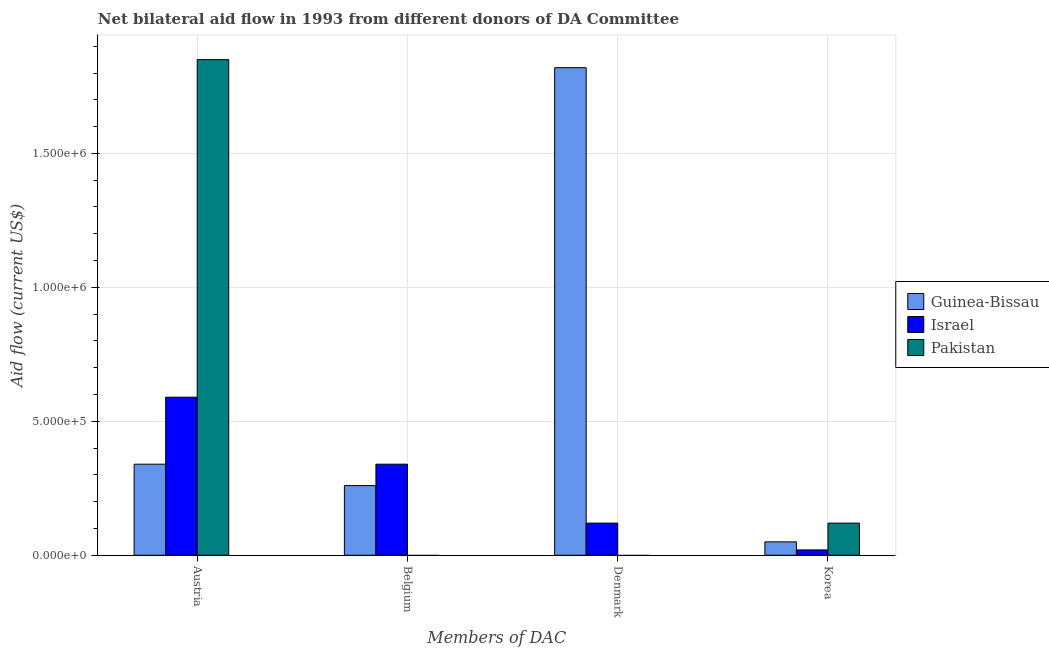How many different coloured bars are there?
Give a very brief answer. 3. How many groups of bars are there?
Your answer should be compact. 4. Are the number of bars on each tick of the X-axis equal?
Offer a terse response. No. How many bars are there on the 2nd tick from the right?
Provide a succinct answer. 2. What is the label of the 3rd group of bars from the left?
Your answer should be compact. Denmark. What is the amount of aid given by austria in Israel?
Provide a short and direct response. 5.90e+05. Across all countries, what is the maximum amount of aid given by korea?
Your response must be concise. 1.20e+05. Across all countries, what is the minimum amount of aid given by denmark?
Your answer should be compact. 0. What is the total amount of aid given by austria in the graph?
Offer a very short reply. 2.78e+06. What is the difference between the amount of aid given by korea in Pakistan and that in Israel?
Provide a short and direct response. 1.00e+05. What is the difference between the amount of aid given by korea in Guinea-Bissau and the amount of aid given by austria in Israel?
Offer a terse response. -5.40e+05. What is the difference between the amount of aid given by korea and amount of aid given by austria in Guinea-Bissau?
Provide a short and direct response. -2.90e+05. In how many countries, is the amount of aid given by korea greater than 700000 US$?
Provide a short and direct response. 0. What is the ratio of the amount of aid given by austria in Guinea-Bissau to that in Israel?
Provide a short and direct response. 0.58. Is the difference between the amount of aid given by denmark in Israel and Guinea-Bissau greater than the difference between the amount of aid given by korea in Israel and Guinea-Bissau?
Give a very brief answer. No. What is the difference between the highest and the lowest amount of aid given by denmark?
Give a very brief answer. 1.82e+06. In how many countries, is the amount of aid given by belgium greater than the average amount of aid given by belgium taken over all countries?
Ensure brevity in your answer.  2. Is the sum of the amount of aid given by denmark in Israel and Guinea-Bissau greater than the maximum amount of aid given by austria across all countries?
Provide a short and direct response. Yes. Is it the case that in every country, the sum of the amount of aid given by austria and amount of aid given by belgium is greater than the amount of aid given by denmark?
Offer a very short reply. No. How many countries are there in the graph?
Ensure brevity in your answer.  3. What is the difference between two consecutive major ticks on the Y-axis?
Ensure brevity in your answer.  5.00e+05. Are the values on the major ticks of Y-axis written in scientific E-notation?
Make the answer very short. Yes. Does the graph contain grids?
Your answer should be very brief. Yes. Where does the legend appear in the graph?
Keep it short and to the point. Center right. What is the title of the graph?
Offer a very short reply. Net bilateral aid flow in 1993 from different donors of DA Committee. What is the label or title of the X-axis?
Give a very brief answer. Members of DAC. What is the label or title of the Y-axis?
Provide a succinct answer. Aid flow (current US$). What is the Aid flow (current US$) in Israel in Austria?
Offer a very short reply. 5.90e+05. What is the Aid flow (current US$) in Pakistan in Austria?
Give a very brief answer. 1.85e+06. What is the Aid flow (current US$) in Guinea-Bissau in Belgium?
Offer a terse response. 2.60e+05. What is the Aid flow (current US$) in Israel in Belgium?
Provide a succinct answer. 3.40e+05. What is the Aid flow (current US$) of Pakistan in Belgium?
Provide a succinct answer. 0. What is the Aid flow (current US$) of Guinea-Bissau in Denmark?
Your response must be concise. 1.82e+06. What is the Aid flow (current US$) in Israel in Denmark?
Give a very brief answer. 1.20e+05. What is the Aid flow (current US$) of Pakistan in Denmark?
Provide a short and direct response. 0. What is the Aid flow (current US$) of Pakistan in Korea?
Offer a terse response. 1.20e+05. Across all Members of DAC, what is the maximum Aid flow (current US$) of Guinea-Bissau?
Provide a short and direct response. 1.82e+06. Across all Members of DAC, what is the maximum Aid flow (current US$) in Israel?
Your response must be concise. 5.90e+05. Across all Members of DAC, what is the maximum Aid flow (current US$) of Pakistan?
Offer a very short reply. 1.85e+06. Across all Members of DAC, what is the minimum Aid flow (current US$) in Guinea-Bissau?
Your response must be concise. 5.00e+04. Across all Members of DAC, what is the minimum Aid flow (current US$) in Israel?
Keep it short and to the point. 2.00e+04. What is the total Aid flow (current US$) in Guinea-Bissau in the graph?
Your response must be concise. 2.47e+06. What is the total Aid flow (current US$) in Israel in the graph?
Provide a succinct answer. 1.07e+06. What is the total Aid flow (current US$) in Pakistan in the graph?
Your answer should be very brief. 1.97e+06. What is the difference between the Aid flow (current US$) in Guinea-Bissau in Austria and that in Denmark?
Offer a terse response. -1.48e+06. What is the difference between the Aid flow (current US$) of Israel in Austria and that in Denmark?
Offer a terse response. 4.70e+05. What is the difference between the Aid flow (current US$) of Israel in Austria and that in Korea?
Your answer should be compact. 5.70e+05. What is the difference between the Aid flow (current US$) of Pakistan in Austria and that in Korea?
Offer a terse response. 1.73e+06. What is the difference between the Aid flow (current US$) of Guinea-Bissau in Belgium and that in Denmark?
Offer a terse response. -1.56e+06. What is the difference between the Aid flow (current US$) of Israel in Belgium and that in Denmark?
Your answer should be very brief. 2.20e+05. What is the difference between the Aid flow (current US$) of Guinea-Bissau in Belgium and that in Korea?
Ensure brevity in your answer.  2.10e+05. What is the difference between the Aid flow (current US$) of Guinea-Bissau in Denmark and that in Korea?
Your answer should be very brief. 1.77e+06. What is the difference between the Aid flow (current US$) in Israel in Denmark and that in Korea?
Keep it short and to the point. 1.00e+05. What is the difference between the Aid flow (current US$) in Guinea-Bissau in Belgium and the Aid flow (current US$) in Israel in Denmark?
Ensure brevity in your answer.  1.40e+05. What is the difference between the Aid flow (current US$) in Guinea-Bissau in Denmark and the Aid flow (current US$) in Israel in Korea?
Provide a succinct answer. 1.80e+06. What is the difference between the Aid flow (current US$) of Guinea-Bissau in Denmark and the Aid flow (current US$) of Pakistan in Korea?
Offer a very short reply. 1.70e+06. What is the average Aid flow (current US$) in Guinea-Bissau per Members of DAC?
Make the answer very short. 6.18e+05. What is the average Aid flow (current US$) of Israel per Members of DAC?
Offer a very short reply. 2.68e+05. What is the average Aid flow (current US$) of Pakistan per Members of DAC?
Offer a very short reply. 4.92e+05. What is the difference between the Aid flow (current US$) in Guinea-Bissau and Aid flow (current US$) in Pakistan in Austria?
Provide a short and direct response. -1.51e+06. What is the difference between the Aid flow (current US$) in Israel and Aid flow (current US$) in Pakistan in Austria?
Keep it short and to the point. -1.26e+06. What is the difference between the Aid flow (current US$) in Guinea-Bissau and Aid flow (current US$) in Israel in Denmark?
Provide a short and direct response. 1.70e+06. What is the difference between the Aid flow (current US$) of Guinea-Bissau and Aid flow (current US$) of Israel in Korea?
Your answer should be compact. 3.00e+04. What is the difference between the Aid flow (current US$) in Israel and Aid flow (current US$) in Pakistan in Korea?
Offer a terse response. -1.00e+05. What is the ratio of the Aid flow (current US$) of Guinea-Bissau in Austria to that in Belgium?
Your answer should be compact. 1.31. What is the ratio of the Aid flow (current US$) in Israel in Austria to that in Belgium?
Your answer should be compact. 1.74. What is the ratio of the Aid flow (current US$) in Guinea-Bissau in Austria to that in Denmark?
Provide a succinct answer. 0.19. What is the ratio of the Aid flow (current US$) in Israel in Austria to that in Denmark?
Your answer should be very brief. 4.92. What is the ratio of the Aid flow (current US$) in Guinea-Bissau in Austria to that in Korea?
Give a very brief answer. 6.8. What is the ratio of the Aid flow (current US$) of Israel in Austria to that in Korea?
Offer a very short reply. 29.5. What is the ratio of the Aid flow (current US$) of Pakistan in Austria to that in Korea?
Give a very brief answer. 15.42. What is the ratio of the Aid flow (current US$) in Guinea-Bissau in Belgium to that in Denmark?
Your response must be concise. 0.14. What is the ratio of the Aid flow (current US$) in Israel in Belgium to that in Denmark?
Ensure brevity in your answer.  2.83. What is the ratio of the Aid flow (current US$) in Guinea-Bissau in Belgium to that in Korea?
Your response must be concise. 5.2. What is the ratio of the Aid flow (current US$) in Israel in Belgium to that in Korea?
Offer a terse response. 17. What is the ratio of the Aid flow (current US$) of Guinea-Bissau in Denmark to that in Korea?
Your answer should be compact. 36.4. What is the ratio of the Aid flow (current US$) of Israel in Denmark to that in Korea?
Offer a terse response. 6. What is the difference between the highest and the second highest Aid flow (current US$) of Guinea-Bissau?
Your answer should be compact. 1.48e+06. What is the difference between the highest and the second highest Aid flow (current US$) of Israel?
Ensure brevity in your answer.  2.50e+05. What is the difference between the highest and the lowest Aid flow (current US$) in Guinea-Bissau?
Your answer should be compact. 1.77e+06. What is the difference between the highest and the lowest Aid flow (current US$) of Israel?
Make the answer very short. 5.70e+05. What is the difference between the highest and the lowest Aid flow (current US$) in Pakistan?
Your response must be concise. 1.85e+06. 